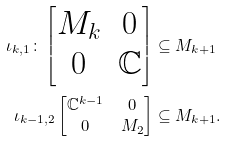Convert formula to latex. <formula><loc_0><loc_0><loc_500><loc_500>\iota _ { k , 1 } \colon \begin{bmatrix} M _ { k } & 0 \\ 0 & \mathbb { C } \end{bmatrix} & \subseteq M _ { k + 1 } \\ \iota _ { k - 1 , 2 } \begin{bmatrix} \mathbb { C } ^ { k - 1 } & 0 \\ 0 & M _ { 2 } \end{bmatrix} & \subseteq M _ { k + 1 } .</formula> 